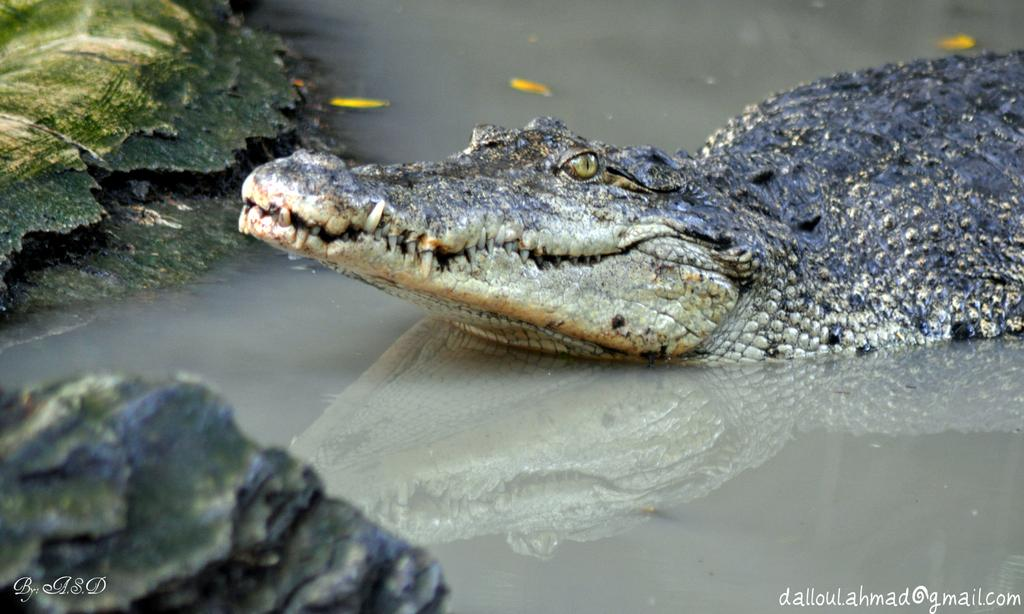What is the main subject in the center of the image? There is a crocodile in the center of the image. What is the crocodile's location in relation to the water? The crocodile is on the water. What can be seen on the left side of the image? There are rocks on the left side of the image. What type of root can be seen growing in the farmer's garden in the image? There is no farmer or garden present in the image; it features a crocodile on the water with rocks on the left side. 